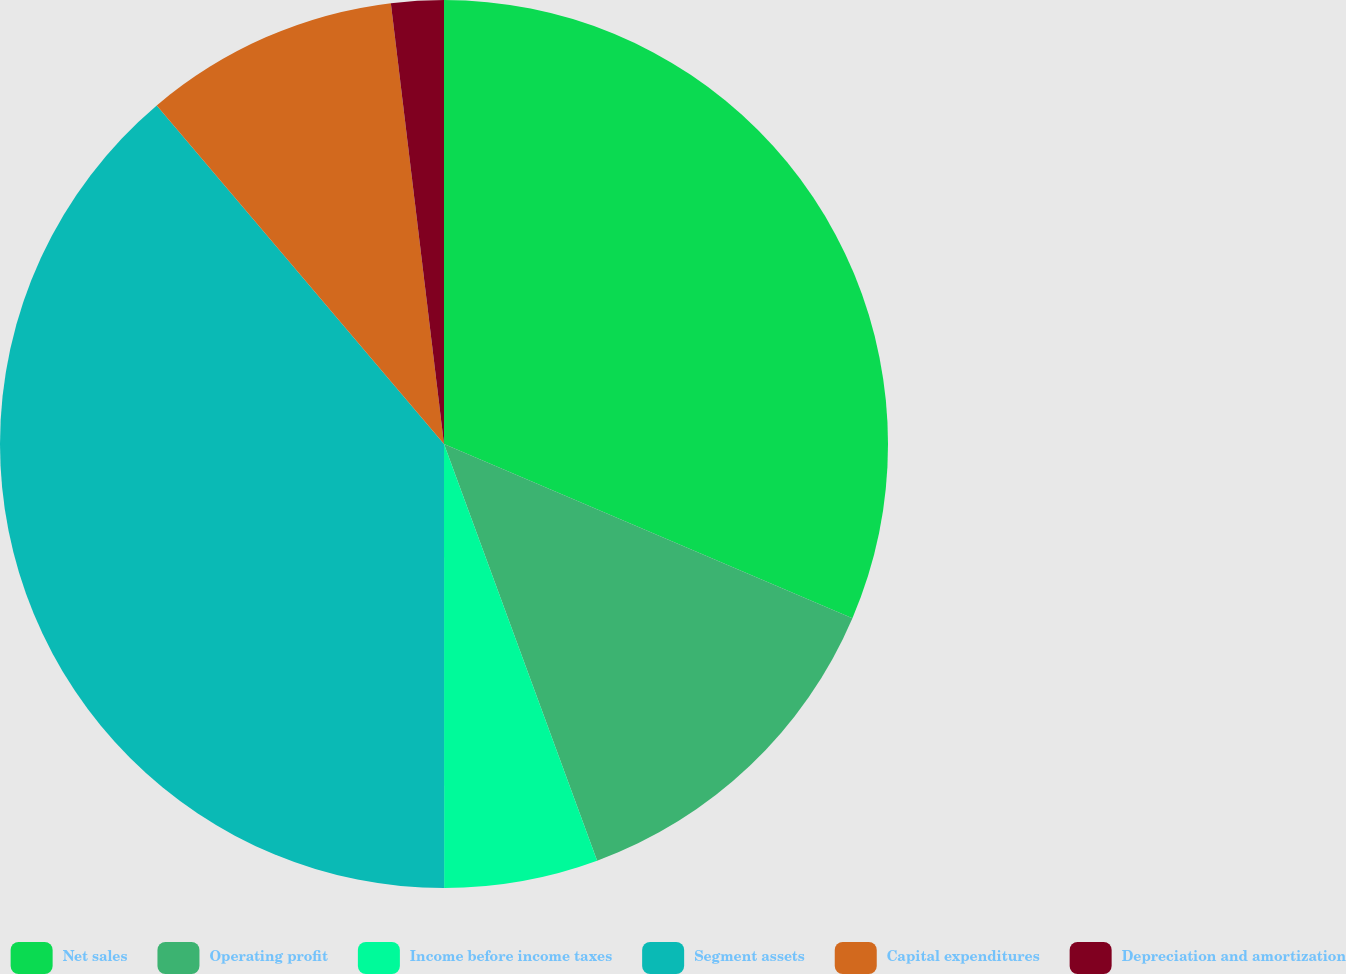Convert chart. <chart><loc_0><loc_0><loc_500><loc_500><pie_chart><fcel>Net sales<fcel>Operating profit<fcel>Income before income taxes<fcel>Segment assets<fcel>Capital expenditures<fcel>Depreciation and amortization<nl><fcel>31.42%<fcel>12.98%<fcel>5.6%<fcel>38.81%<fcel>9.29%<fcel>1.91%<nl></chart> 